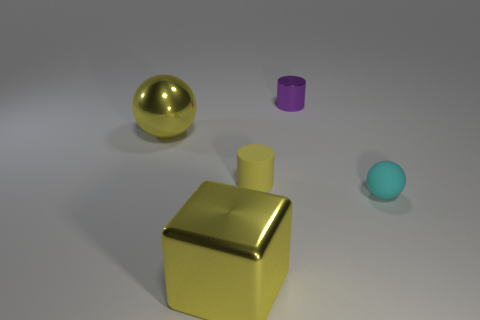Add 5 yellow matte cylinders. How many objects exist? 10 Subtract all spheres. How many objects are left? 3 Add 2 cubes. How many cubes are left? 3 Add 3 yellow cylinders. How many yellow cylinders exist? 4 Subtract 0 cyan cylinders. How many objects are left? 5 Subtract all large blue things. Subtract all tiny cyan rubber balls. How many objects are left? 4 